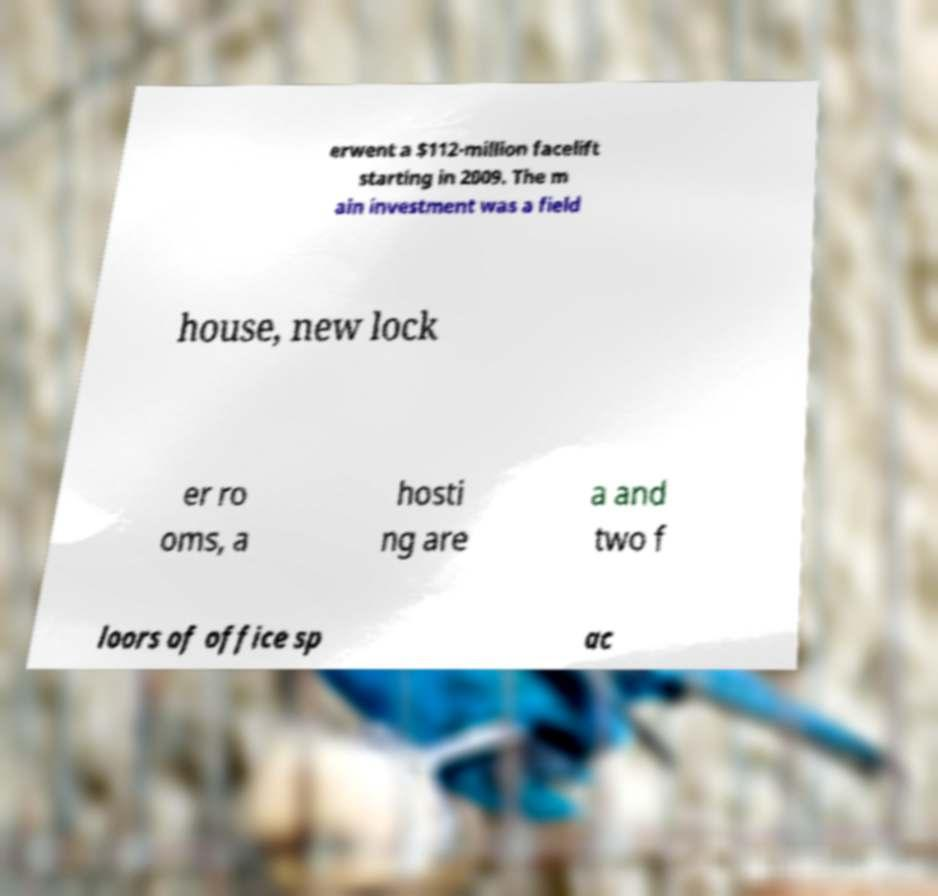For documentation purposes, I need the text within this image transcribed. Could you provide that? erwent a $112-million facelift starting in 2009. The m ain investment was a field house, new lock er ro oms, a hosti ng are a and two f loors of office sp ac 